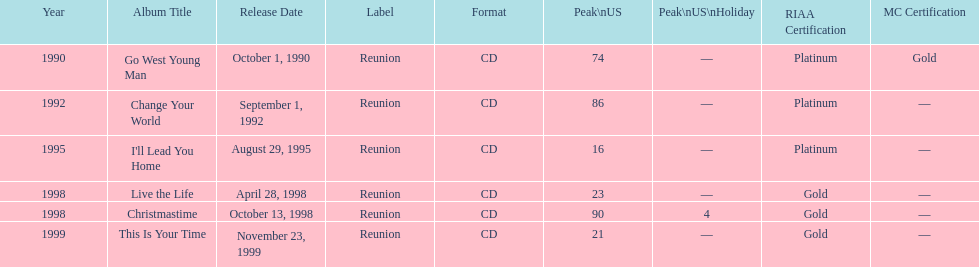What michael w smith album was released before his christmastime album? Live the Life. 